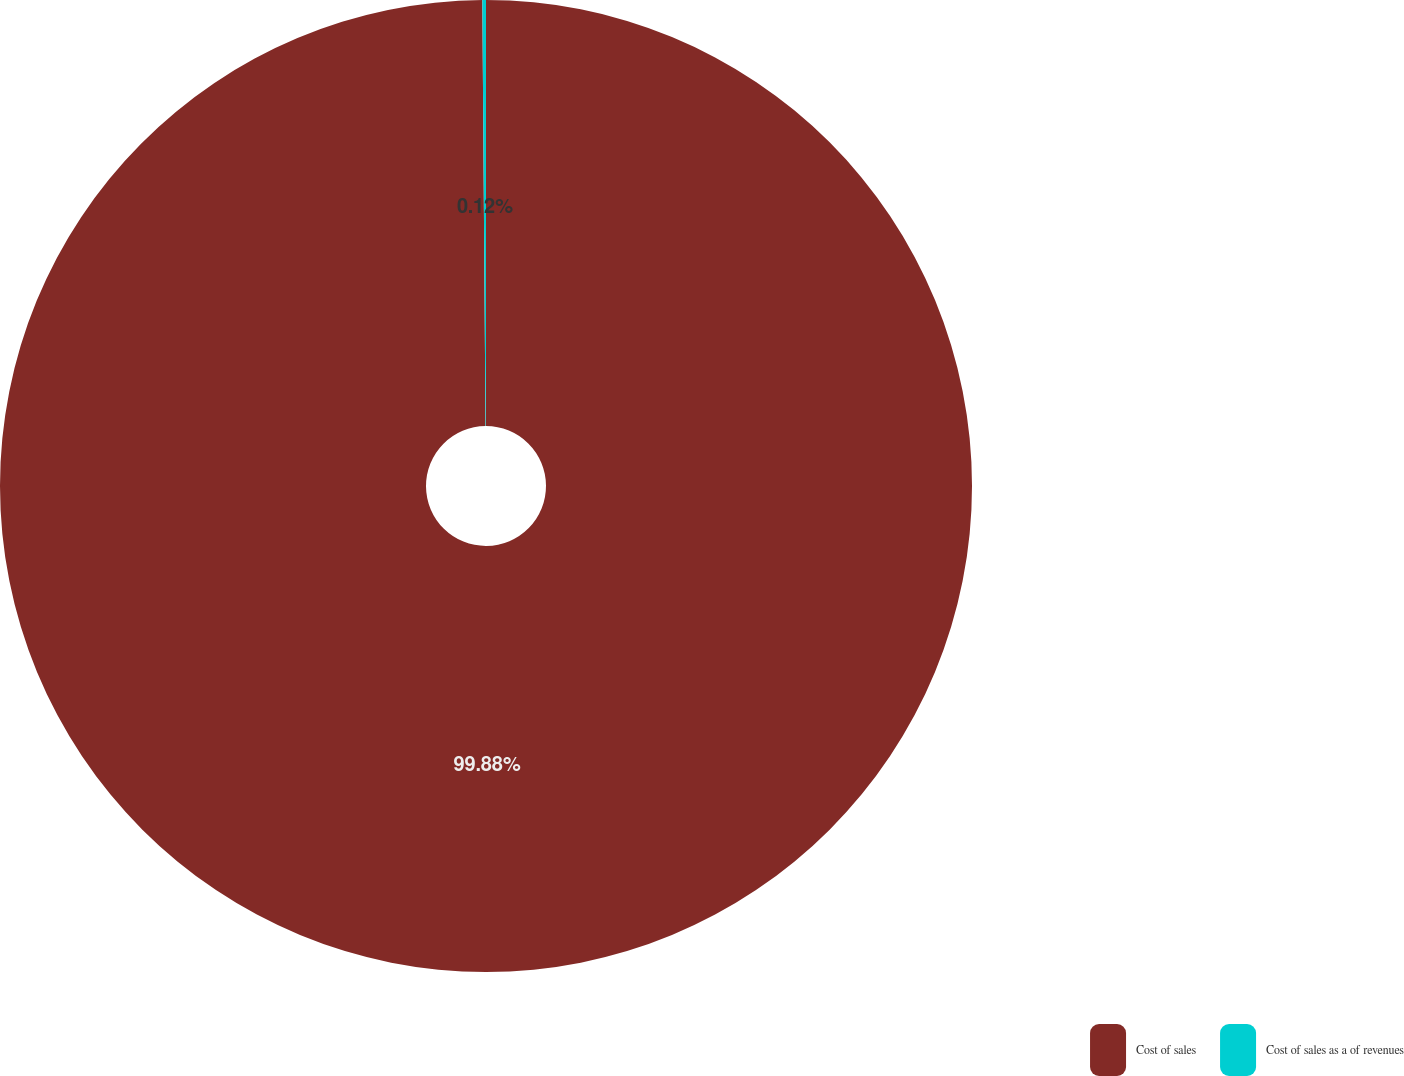<chart> <loc_0><loc_0><loc_500><loc_500><pie_chart><fcel>Cost of sales<fcel>Cost of sales as a of revenues<nl><fcel>99.88%<fcel>0.12%<nl></chart> 